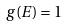<formula> <loc_0><loc_0><loc_500><loc_500>g ( E ) = 1</formula> 